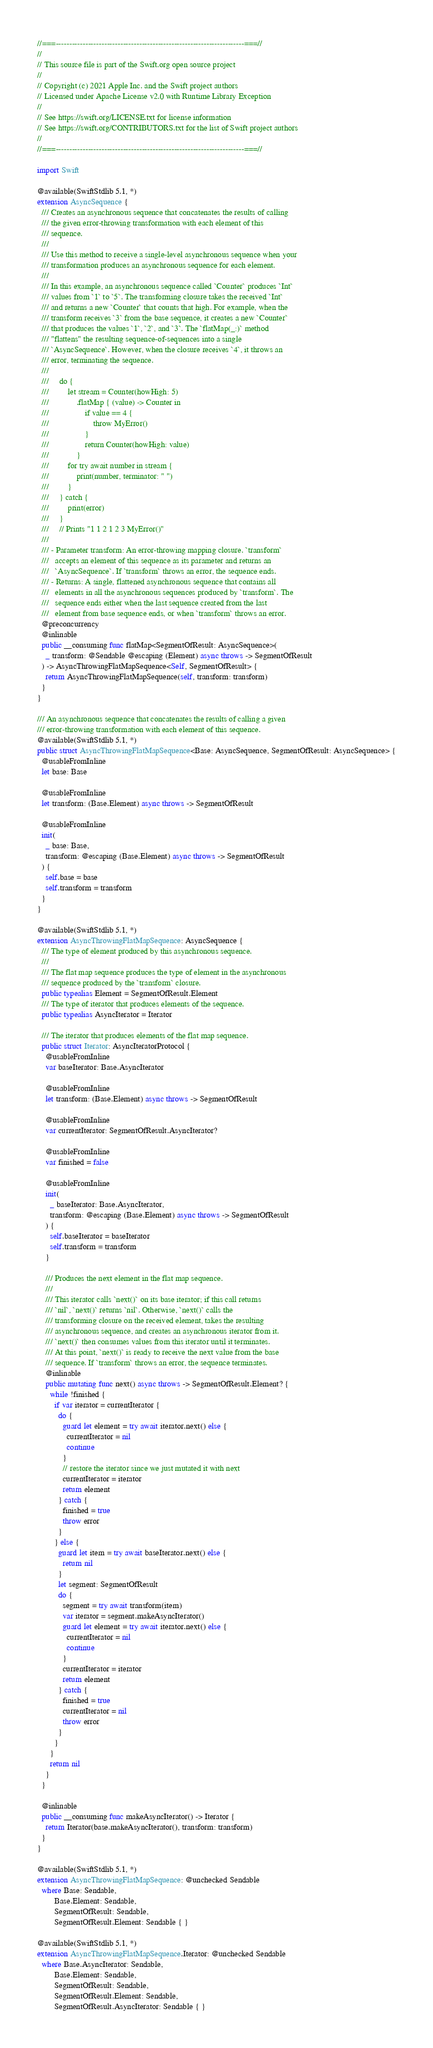<code> <loc_0><loc_0><loc_500><loc_500><_Swift_>//===----------------------------------------------------------------------===//
//
// This source file is part of the Swift.org open source project
//
// Copyright (c) 2021 Apple Inc. and the Swift project authors
// Licensed under Apache License v2.0 with Runtime Library Exception
//
// See https://swift.org/LICENSE.txt for license information
// See https://swift.org/CONTRIBUTORS.txt for the list of Swift project authors
//
//===----------------------------------------------------------------------===//

import Swift

@available(SwiftStdlib 5.1, *)
extension AsyncSequence {
  /// Creates an asynchronous sequence that concatenates the results of calling
  /// the given error-throwing transformation with each element of this
  /// sequence.
  ///
  /// Use this method to receive a single-level asynchronous sequence when your
  /// transformation produces an asynchronous sequence for each element.
  ///
  /// In this example, an asynchronous sequence called `Counter` produces `Int`
  /// values from `1` to `5`. The transforming closure takes the received `Int`
  /// and returns a new `Counter` that counts that high. For example, when the
  /// transform receives `3` from the base sequence, it creates a new `Counter`
  /// that produces the values `1`, `2`, and `3`. The `flatMap(_:)` method
  /// "flattens" the resulting sequence-of-sequences into a single
  /// `AsyncSequence`. However, when the closure receives `4`, it throws an
  /// error, terminating the sequence.
  ///
  ///     do {
  ///         let stream = Counter(howHigh: 5)
  ///             .flatMap { (value) -> Counter in
  ///                 if value == 4 {
  ///                     throw MyError()
  ///                 }
  ///                 return Counter(howHigh: value)
  ///             }
  ///         for try await number in stream {
  ///             print(number, terminator: " ")
  ///         }
  ///     } catch {
  ///         print(error)
  ///     }
  ///     // Prints "1 1 2 1 2 3 MyError()"
  ///
  /// - Parameter transform: An error-throwing mapping closure. `transform`
  ///   accepts an element of this sequence as its parameter and returns an
  ///   `AsyncSequence`. If `transform` throws an error, the sequence ends.
  /// - Returns: A single, flattened asynchronous sequence that contains all
  ///   elements in all the asynchronous sequences produced by `transform`. The
  ///   sequence ends either when the last sequence created from the last
  ///   element from base sequence ends, or when `transform` throws an error.
  @preconcurrency
  @inlinable
  public __consuming func flatMap<SegmentOfResult: AsyncSequence>(
    _ transform: @Sendable @escaping (Element) async throws -> SegmentOfResult
  ) -> AsyncThrowingFlatMapSequence<Self, SegmentOfResult> {
    return AsyncThrowingFlatMapSequence(self, transform: transform)
  }
}

/// An asynchronous sequence that concatenates the results of calling a given
/// error-throwing transformation with each element of this sequence.
@available(SwiftStdlib 5.1, *)
public struct AsyncThrowingFlatMapSequence<Base: AsyncSequence, SegmentOfResult: AsyncSequence> {
  @usableFromInline
  let base: Base

  @usableFromInline
  let transform: (Base.Element) async throws -> SegmentOfResult

  @usableFromInline
  init(
    _ base: Base,
    transform: @escaping (Base.Element) async throws -> SegmentOfResult
  ) {
    self.base = base
    self.transform = transform
  }
}

@available(SwiftStdlib 5.1, *)
extension AsyncThrowingFlatMapSequence: AsyncSequence {
  /// The type of element produced by this asynchronous sequence.
  ///
  /// The flat map sequence produces the type of element in the asynchronous
  /// sequence produced by the `transform` closure.
  public typealias Element = SegmentOfResult.Element
  /// The type of iterator that produces elements of the sequence.
  public typealias AsyncIterator = Iterator

  /// The iterator that produces elements of the flat map sequence.
  public struct Iterator: AsyncIteratorProtocol {
    @usableFromInline
    var baseIterator: Base.AsyncIterator

    @usableFromInline
    let transform: (Base.Element) async throws -> SegmentOfResult

    @usableFromInline
    var currentIterator: SegmentOfResult.AsyncIterator?

    @usableFromInline
    var finished = false

    @usableFromInline
    init(
      _ baseIterator: Base.AsyncIterator,
      transform: @escaping (Base.Element) async throws -> SegmentOfResult
    ) {
      self.baseIterator = baseIterator
      self.transform = transform
    }

    /// Produces the next element in the flat map sequence.
    ///
    /// This iterator calls `next()` on its base iterator; if this call returns
    /// `nil`, `next()` returns `nil`. Otherwise, `next()` calls the
    /// transforming closure on the received element, takes the resulting
    /// asynchronous sequence, and creates an asynchronous iterator from it.
    /// `next()` then consumes values from this iterator until it terminates.
    /// At this point, `next()` is ready to receive the next value from the base
    /// sequence. If `transform` throws an error, the sequence terminates.
    @inlinable
    public mutating func next() async throws -> SegmentOfResult.Element? {
      while !finished {
        if var iterator = currentIterator {
          do {
            guard let element = try await iterator.next() else {
              currentIterator = nil
              continue
            }
            // restore the iterator since we just mutated it with next
            currentIterator = iterator
            return element
          } catch {
            finished = true
            throw error
          }
        } else {
          guard let item = try await baseIterator.next() else {
            return nil
          }
          let segment: SegmentOfResult
          do {
            segment = try await transform(item)
            var iterator = segment.makeAsyncIterator()
            guard let element = try await iterator.next() else {
              currentIterator = nil
              continue
            }
            currentIterator = iterator
            return element
          } catch {
            finished = true
            currentIterator = nil
            throw error
          }
        }
      }
      return nil
    }
  }

  @inlinable
  public __consuming func makeAsyncIterator() -> Iterator {
    return Iterator(base.makeAsyncIterator(), transform: transform)
  }
}

@available(SwiftStdlib 5.1, *)
extension AsyncThrowingFlatMapSequence: @unchecked Sendable 
  where Base: Sendable, 
        Base.Element: Sendable, 
        SegmentOfResult: Sendable, 
        SegmentOfResult.Element: Sendable { }

@available(SwiftStdlib 5.1, *)
extension AsyncThrowingFlatMapSequence.Iterator: @unchecked Sendable 
  where Base.AsyncIterator: Sendable, 
        Base.Element: Sendable, 
        SegmentOfResult: Sendable, 
        SegmentOfResult.Element: Sendable, 
        SegmentOfResult.AsyncIterator: Sendable { }
</code> 